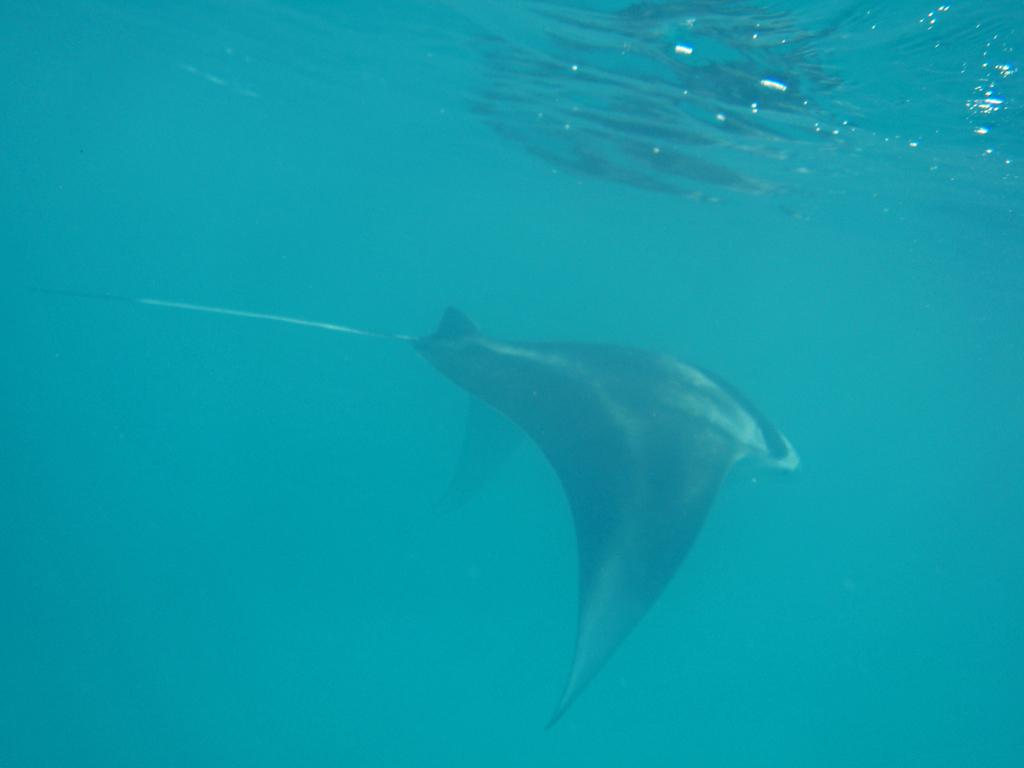What type of animals can be seen in the image? Fish can be seen in the water. What type of locket can be seen hanging from the fish in the image? There is no locket present in the image; it features fish in the water. What wish might the fish be expressing in the image? The image does not depict any wishes being expressed by the fish. 